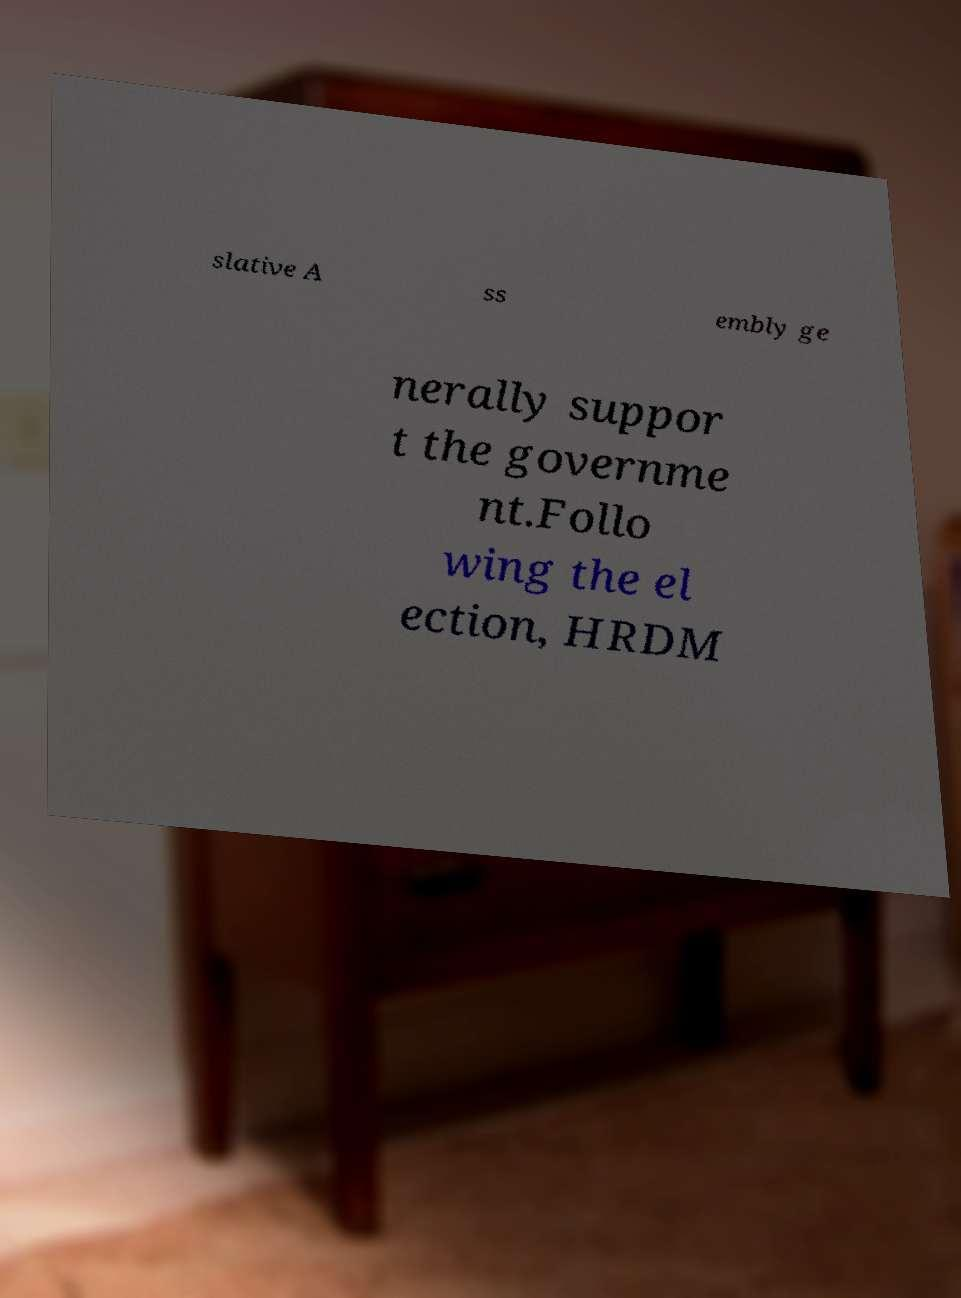Can you read and provide the text displayed in the image?This photo seems to have some interesting text. Can you extract and type it out for me? slative A ss embly ge nerally suppor t the governme nt.Follo wing the el ection, HRDM 